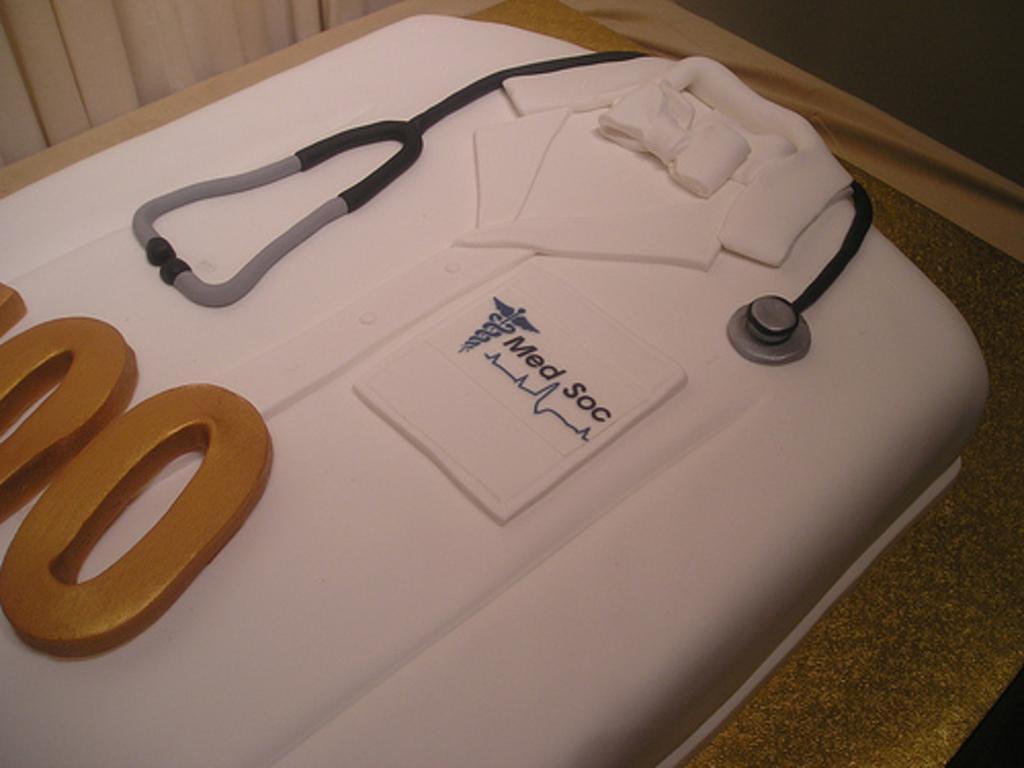Describe this image in one or two sentences. In this picture we can see a cake in the shape of an apron and stethoscope, and also we can see few curtains. 